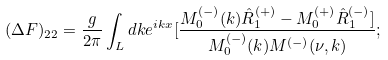<formula> <loc_0><loc_0><loc_500><loc_500>( \Delta F ) _ { 2 2 } = \frac { g } { 2 \pi } \int _ { L } d k e ^ { i k x } [ \frac { M ^ { ( - ) } _ { 0 } ( k ) \hat { R } _ { 1 } ^ { ( + ) } - M ^ { ( + ) } _ { 0 } \hat { R } ^ { ( - ) } _ { 1 } ] } { M ^ { ( - ) } _ { 0 } ( k ) M ^ { ( - ) } ( \nu , k ) } ;</formula> 